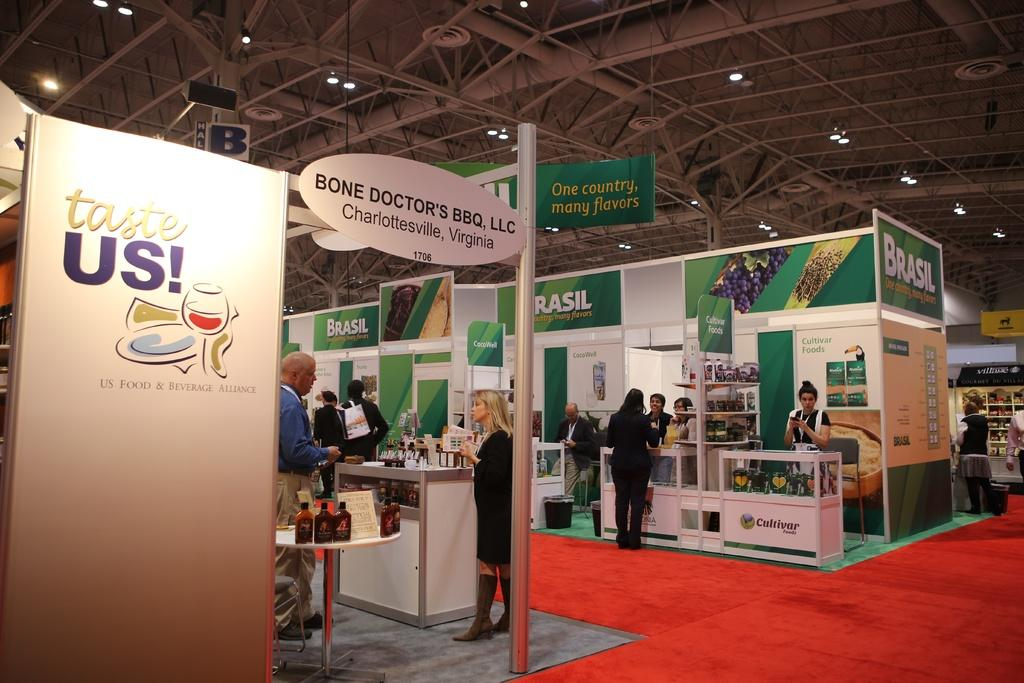<image>
Provide a brief description of the given image. People at a convention with green signs that say Brasil. 